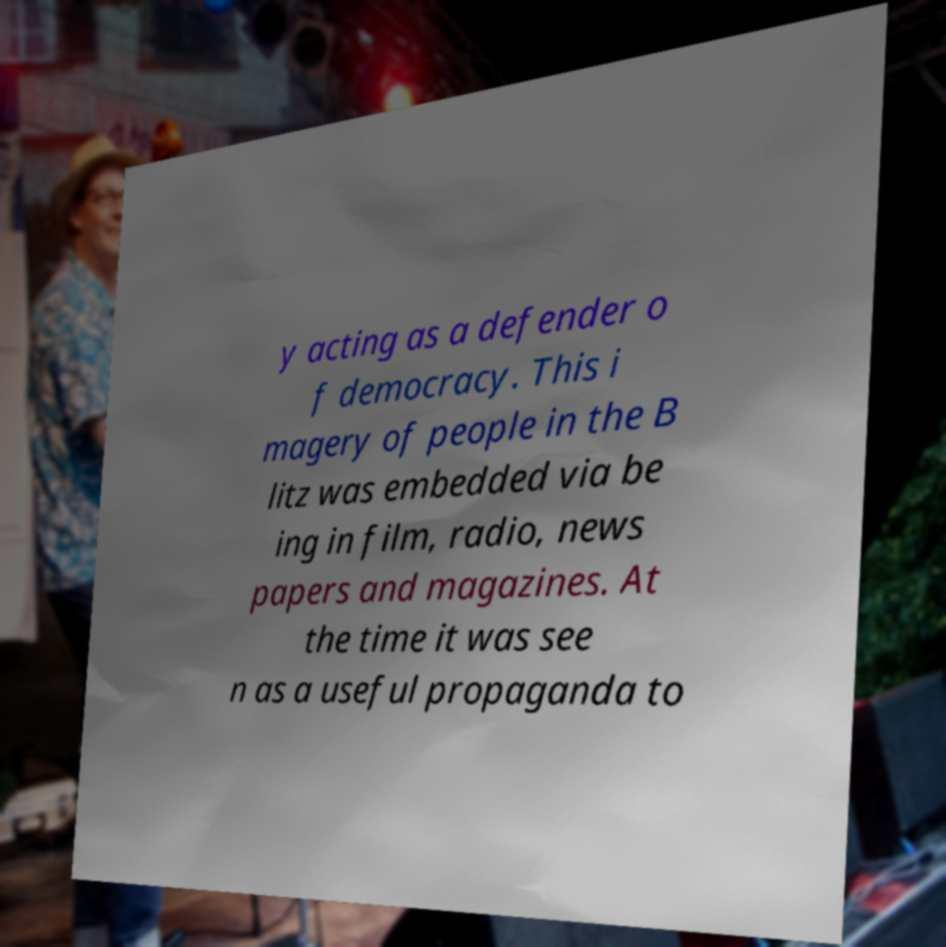Could you assist in decoding the text presented in this image and type it out clearly? y acting as a defender o f democracy. This i magery of people in the B litz was embedded via be ing in film, radio, news papers and magazines. At the time it was see n as a useful propaganda to 